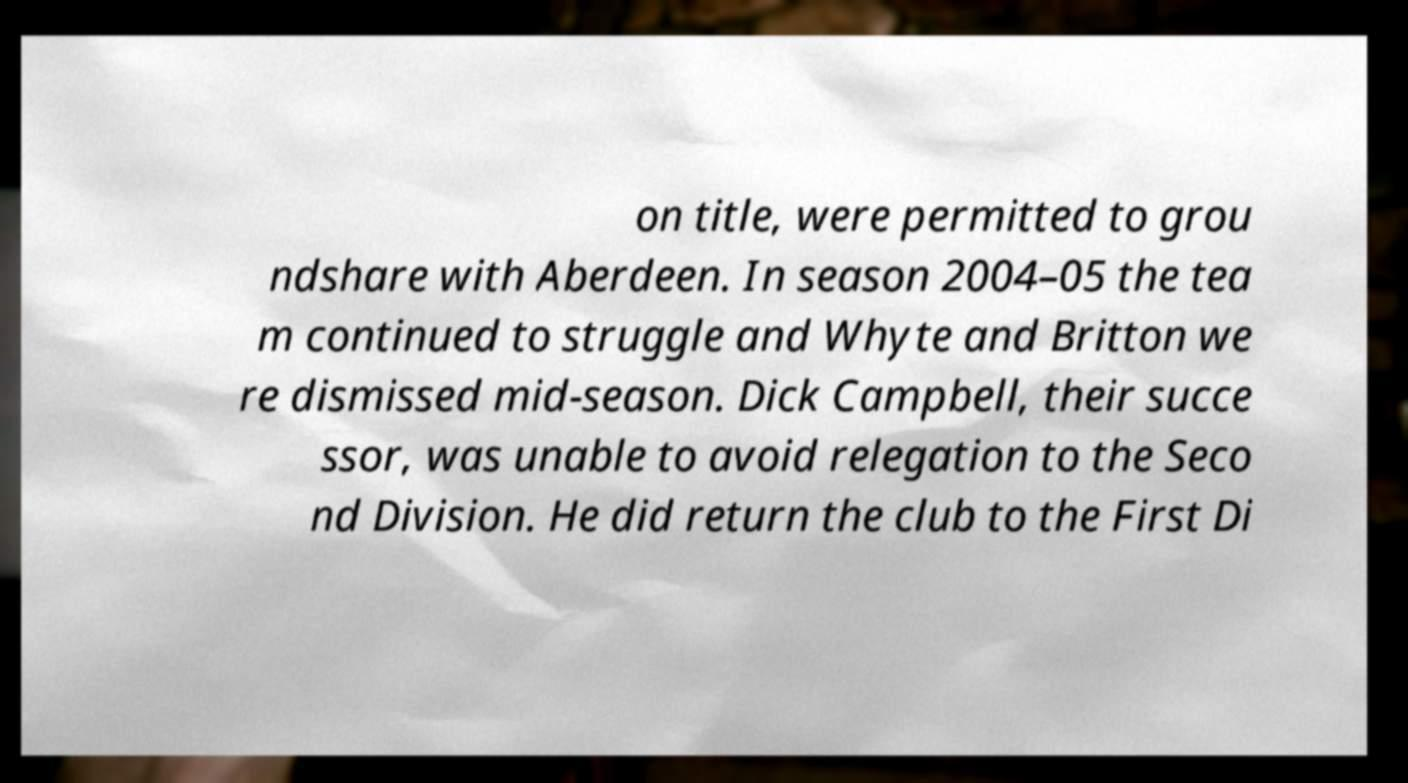Can you read and provide the text displayed in the image?This photo seems to have some interesting text. Can you extract and type it out for me? on title, were permitted to grou ndshare with Aberdeen. In season 2004–05 the tea m continued to struggle and Whyte and Britton we re dismissed mid-season. Dick Campbell, their succe ssor, was unable to avoid relegation to the Seco nd Division. He did return the club to the First Di 